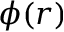Convert formula to latex. <formula><loc_0><loc_0><loc_500><loc_500>\phi ( r )</formula> 